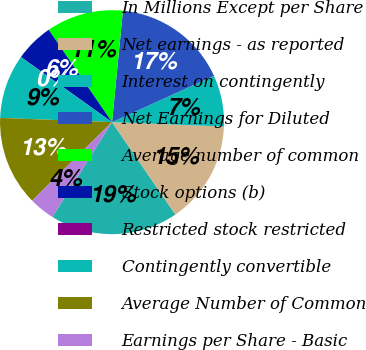Convert chart. <chart><loc_0><loc_0><loc_500><loc_500><pie_chart><fcel>In Millions Except per Share<fcel>Net earnings - as reported<fcel>Interest on contingently<fcel>Net Earnings for Diluted<fcel>Average number of common<fcel>Stock options (b)<fcel>Restricted stock restricted<fcel>Contingently convertible<fcel>Average Number of Common<fcel>Earnings per Share - Basic<nl><fcel>18.51%<fcel>14.81%<fcel>7.41%<fcel>16.66%<fcel>11.11%<fcel>5.56%<fcel>0.01%<fcel>9.26%<fcel>12.96%<fcel>3.71%<nl></chart> 